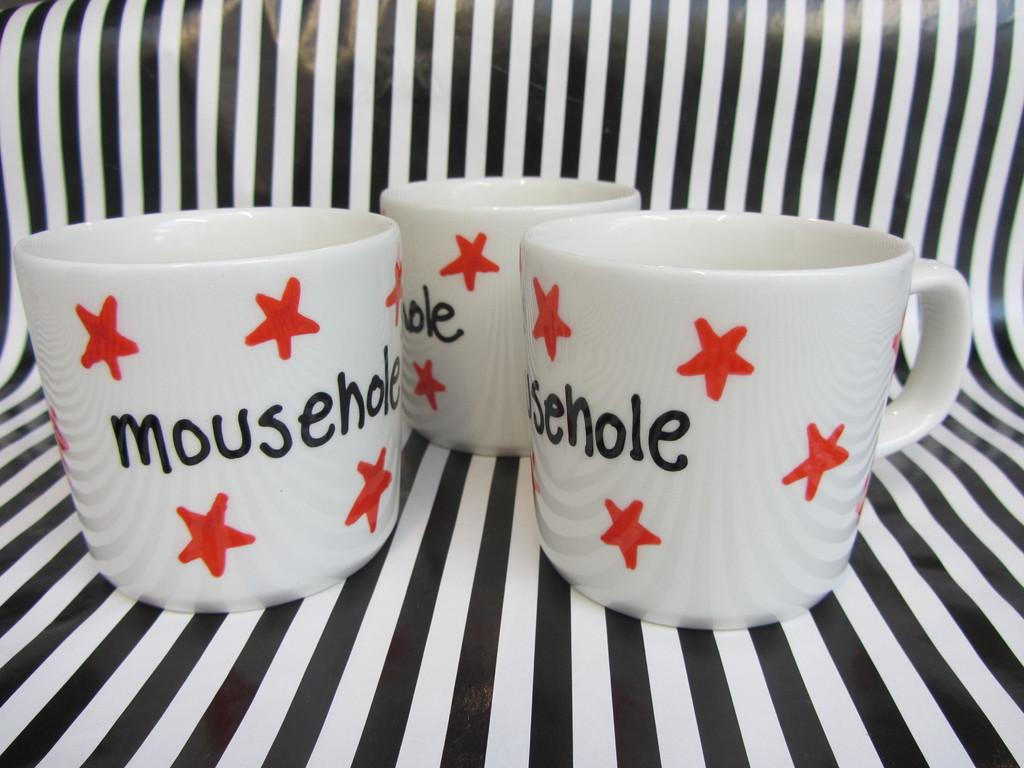How many mugs are visible in the image? There are three mugs in the image. What design element is present on the mugs? The mugs have star symbols on them. Is there any text on the mugs? Yes, there is writing on the mugs. What type of surface are the mugs placed on? The mugs are placed on a black and white surface. What type of lunch is being served in the mugs in the image? There is no lunch present in the image; the mugs are empty and only have star symbols and writing on them. 